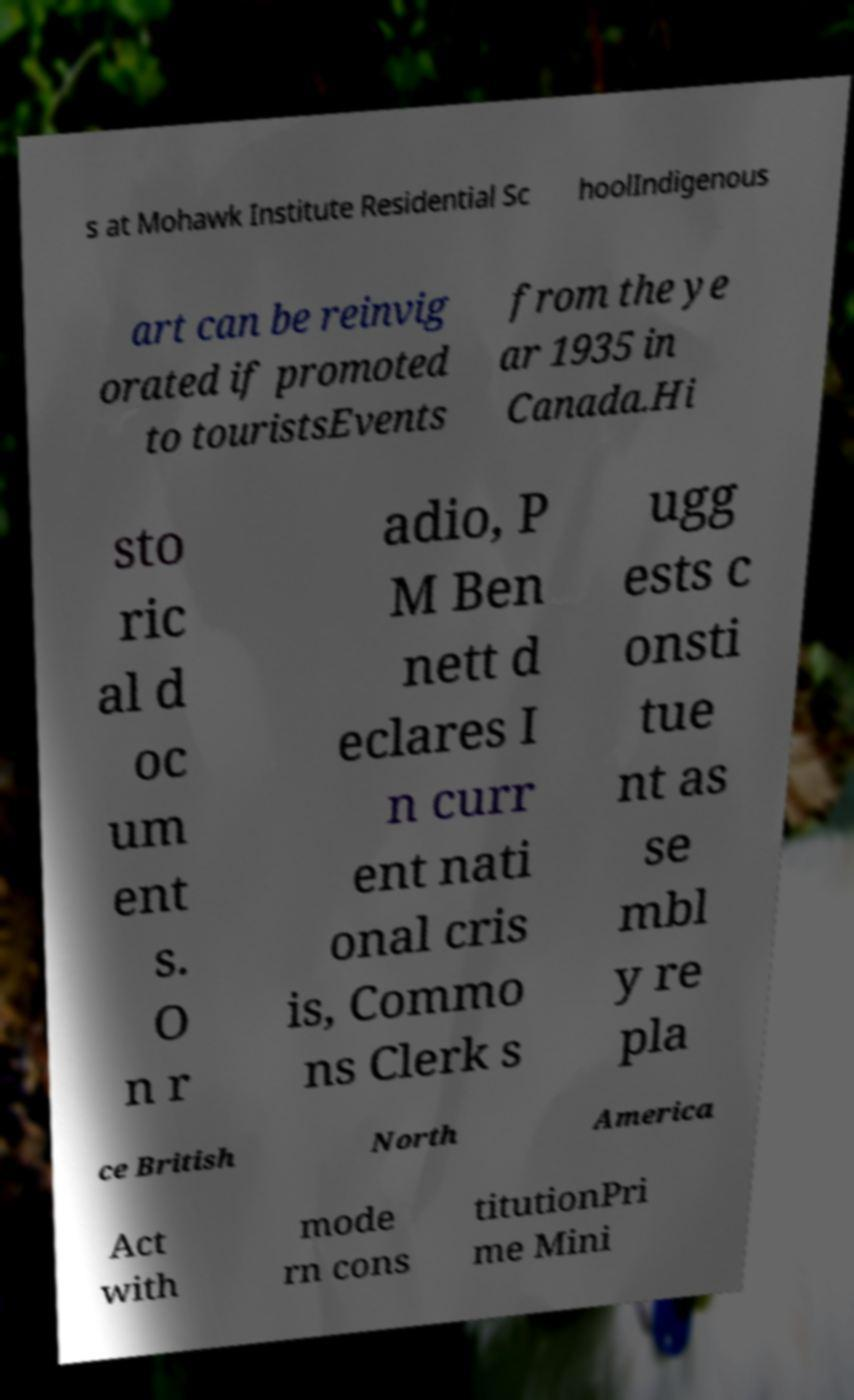Please read and relay the text visible in this image. What does it say? s at Mohawk Institute Residential Sc hoolIndigenous art can be reinvig orated if promoted to touristsEvents from the ye ar 1935 in Canada.Hi sto ric al d oc um ent s. O n r adio, P M Ben nett d eclares I n curr ent nati onal cris is, Commo ns Clerk s ugg ests c onsti tue nt as se mbl y re pla ce British North America Act with mode rn cons titutionPri me Mini 